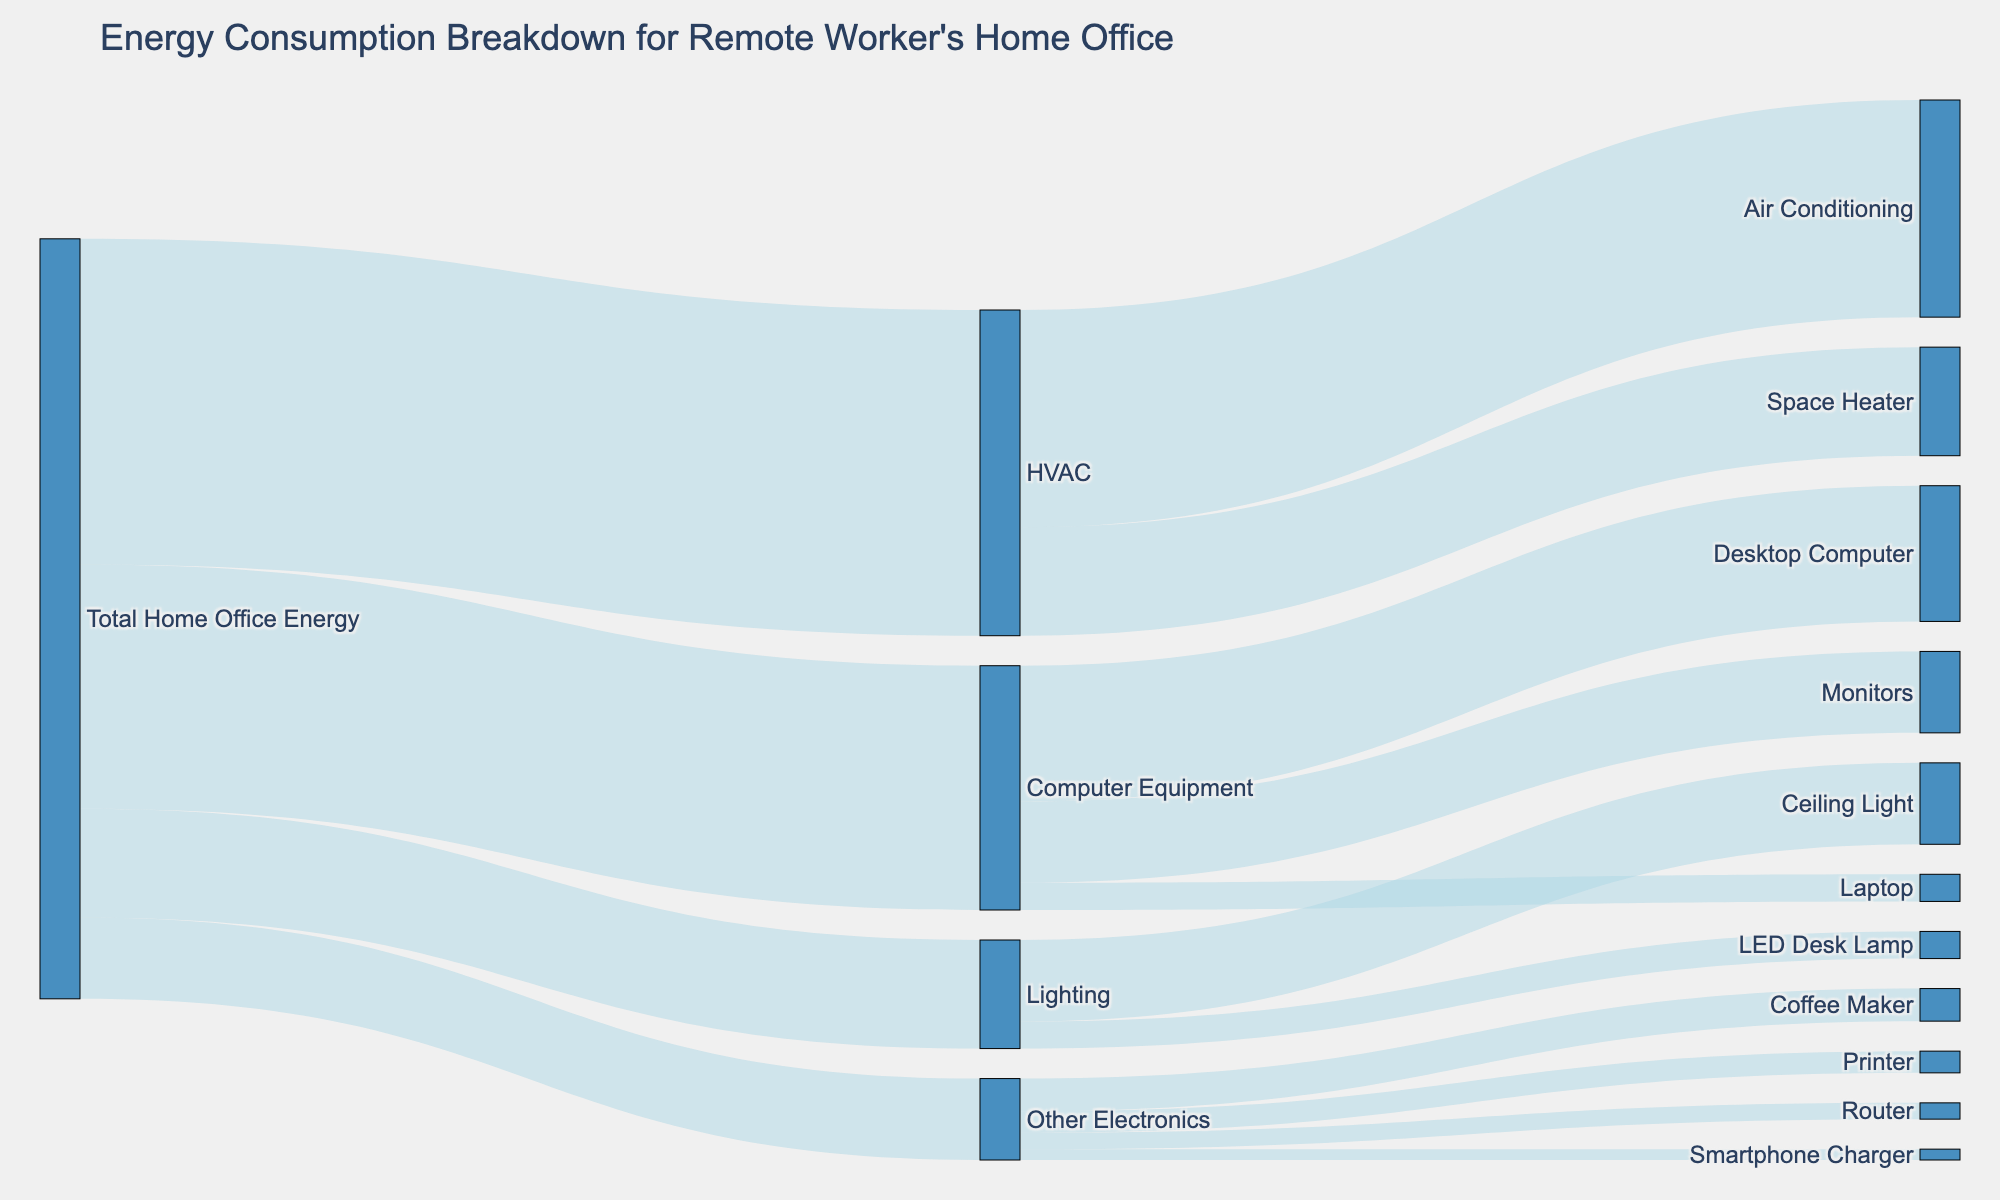What is the largest single category of energy consumption in the home office setup? The diagram shows that the largest category of energy consumption is HVAC. By looking at the values, HVAC uses 600 units, which is more than any other category.
Answer: HVAC Which item consumes the most energy within the Computer Equipment category? To determine the item consuming the most energy within Computer Equipment, we need to compare the values. Desktop Computer consumes 250 units, Monitors consume 150 units, and Laptop consumes 50 units. Therefore, Desktop Computer consumes the most energy in this category.
Answer: Desktop Computer How much total energy is consumed by the Lighting category? To find the total energy consumed by Lighting, sum the energy values of LED Desk Lamp and Ceiling Light. The values are 50 and 150 units respectively. So, the total is 50 + 150 = 200 units.
Answer: 200 units Which specific item in the category HVAC consumes the most energy? By comparing the values in the HVAC category, Air Conditioning consumes 400 units and Space Heater consumes 200 units. Air Conditioning consumes the most energy.
Answer: Air Conditioning How much energy does the Router consume compared to the Coffee Maker? The energy consumption values for Router and Coffee Maker are 30 units and 60 units respectively. The Coffee Maker consumes 30 units more energy than the Router.
Answer: 30 units What is the total energy consumption for Other Electronics? To find the total energy consumption for Other Electronics, sum up the values of Router, Printer, Smartphone Charger, and Coffee Maker. The values are 30, 40, 20, and 60 units respectively. Thus, 30 + 40 + 20 + 60 = 150 units.
Answer: 150 units Which item uses more energy, Air Conditioning or all of the Lighting combined? Air Conditioning uses 400 units. The total energy consumption for Lighting (LED Desk Lamp and Ceiling Light) is 50 + 150 = 200 units. Therefore, Air Conditioning uses more energy than all Lighting combined.
Answer: Air Conditioning Among Desktop Computer, Monitors, and Coffee Maker, which consumes the least energy? Comparing the values: Desktop Computer consumes 250 units, Monitors consume 150 units, and Coffee Maker consumes 60 units. The Coffee Maker consumes the least energy out of these options.
Answer: Coffee Maker 